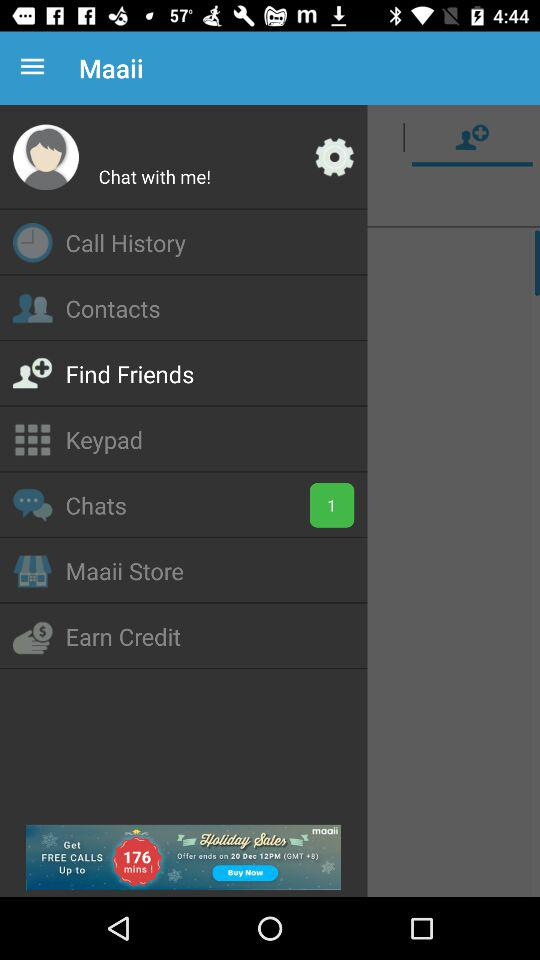Is there any unread chat? There is 1 unread chat. 